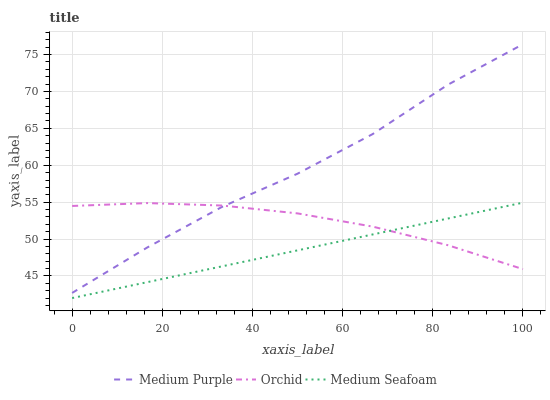Does Medium Seafoam have the minimum area under the curve?
Answer yes or no. Yes. Does Medium Purple have the maximum area under the curve?
Answer yes or no. Yes. Does Orchid have the minimum area under the curve?
Answer yes or no. No. Does Orchid have the maximum area under the curve?
Answer yes or no. No. Is Medium Seafoam the smoothest?
Answer yes or no. Yes. Is Medium Purple the roughest?
Answer yes or no. Yes. Is Orchid the smoothest?
Answer yes or no. No. Is Orchid the roughest?
Answer yes or no. No. Does Orchid have the lowest value?
Answer yes or no. No. Does Medium Purple have the highest value?
Answer yes or no. Yes. Does Medium Seafoam have the highest value?
Answer yes or no. No. Is Medium Seafoam less than Medium Purple?
Answer yes or no. Yes. Is Medium Purple greater than Medium Seafoam?
Answer yes or no. Yes. Does Medium Seafoam intersect Medium Purple?
Answer yes or no. No. 